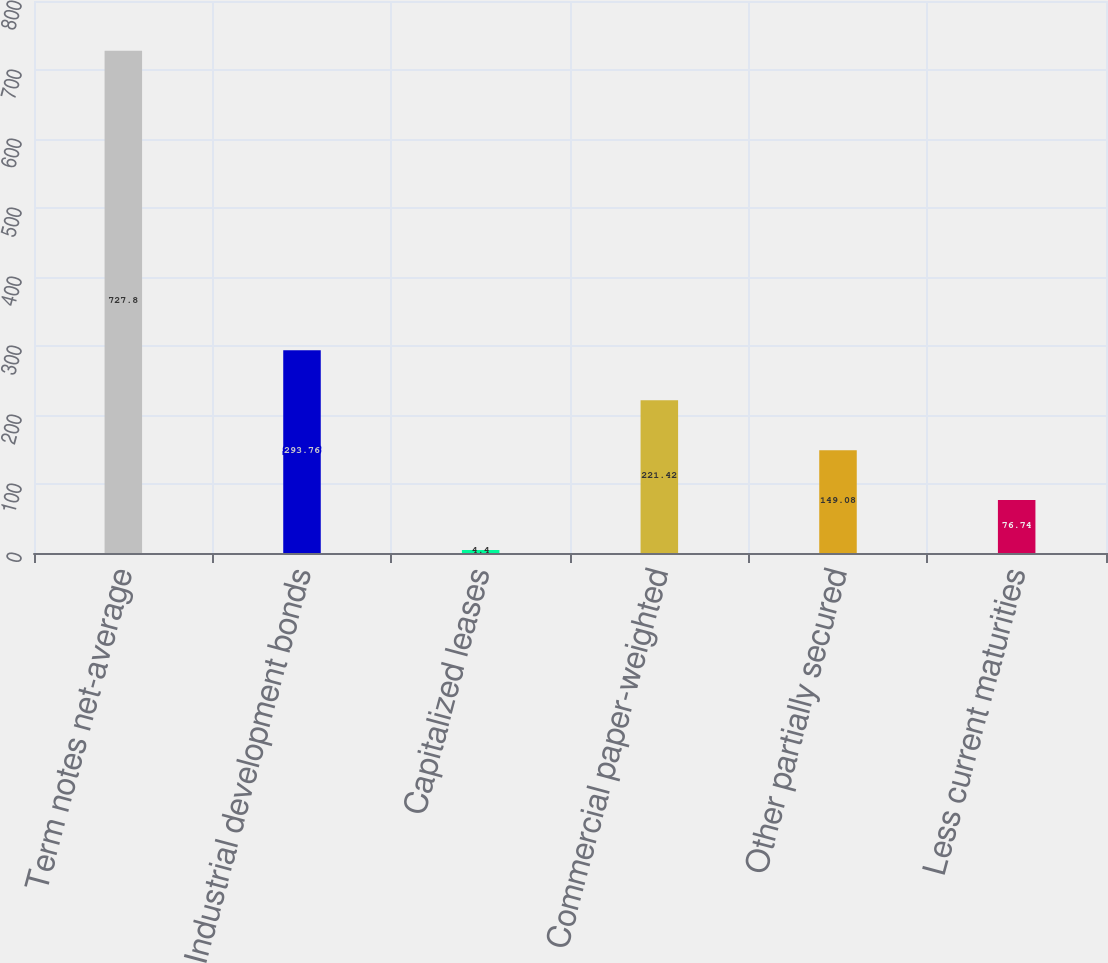Convert chart to OTSL. <chart><loc_0><loc_0><loc_500><loc_500><bar_chart><fcel>Term notes net-average<fcel>Industrial development bonds<fcel>Capitalized leases<fcel>Commercial paper-weighted<fcel>Other partially secured<fcel>Less current maturities<nl><fcel>727.8<fcel>293.76<fcel>4.4<fcel>221.42<fcel>149.08<fcel>76.74<nl></chart> 